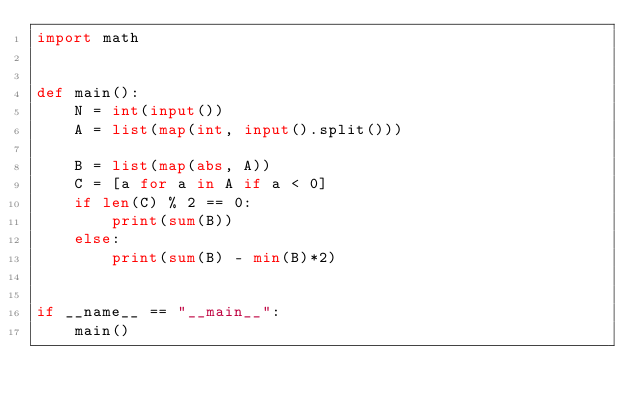Convert code to text. <code><loc_0><loc_0><loc_500><loc_500><_Python_>import math


def main():
    N = int(input())
    A = list(map(int, input().split()))

    B = list(map(abs, A))
    C = [a for a in A if a < 0]
    if len(C) % 2 == 0:
        print(sum(B))
    else:
        print(sum(B) - min(B)*2)
    

if __name__ == "__main__":
    main()
</code> 